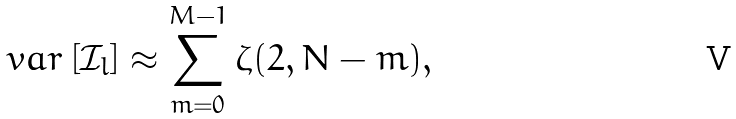<formula> <loc_0><loc_0><loc_500><loc_500>\ v a r \left [ \mathcal { I } _ { l } \right ] \approx \sum _ { m = 0 } ^ { M - 1 } \zeta ( 2 , N - m ) ,</formula> 